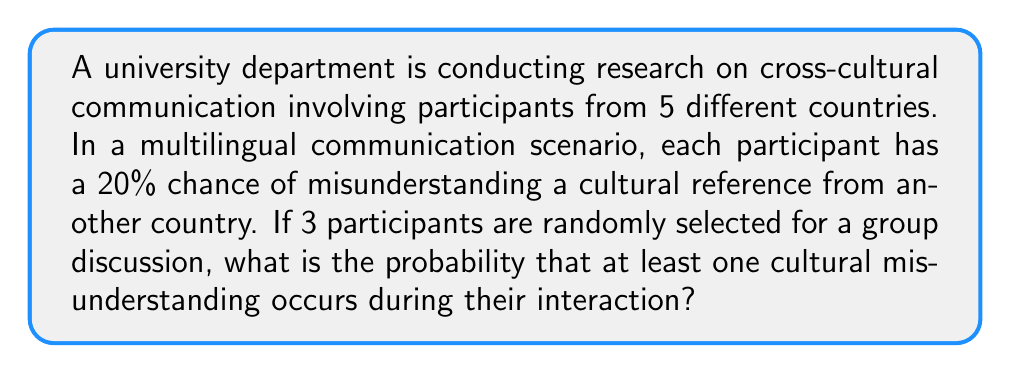Could you help me with this problem? Let's approach this step-by-step:

1) First, we need to calculate the probability of no misunderstandings occurring. This is easier than calculating the probability of at least one misunderstanding directly.

2) For no misunderstandings to occur, each participant must understand all cultural references. The probability of understanding for each participant is:

   $P(\text{understanding}) = 1 - P(\text{misunderstanding}) = 1 - 0.20 = 0.80$ or $80\%$

3) For all three participants to understand, we multiply these individual probabilities:

   $P(\text{all understand}) = 0.80 \times 0.80 \times 0.80 = 0.80^3 = 0.512$ or $51.2\%$

4) Therefore, the probability of at least one misunderstanding is the complement of this probability:

   $P(\text{at least one misunderstanding}) = 1 - P(\text{all understand})$
   $= 1 - 0.512 = 0.488$ or $48.8\%$

5) We can also calculate this using the binomial probability formula:

   $P(X \geq 1) = 1 - P(X = 0)$, where $X$ is the number of misunderstandings

   $P(X = 0) = \binom{3}{0} (0.20)^0 (0.80)^3 = 1 \times 1 \times 0.512 = 0.512$

   $P(X \geq 1) = 1 - 0.512 = 0.488$

This confirms our earlier calculation.
Answer: $0.488$ or $48.8\%$ 